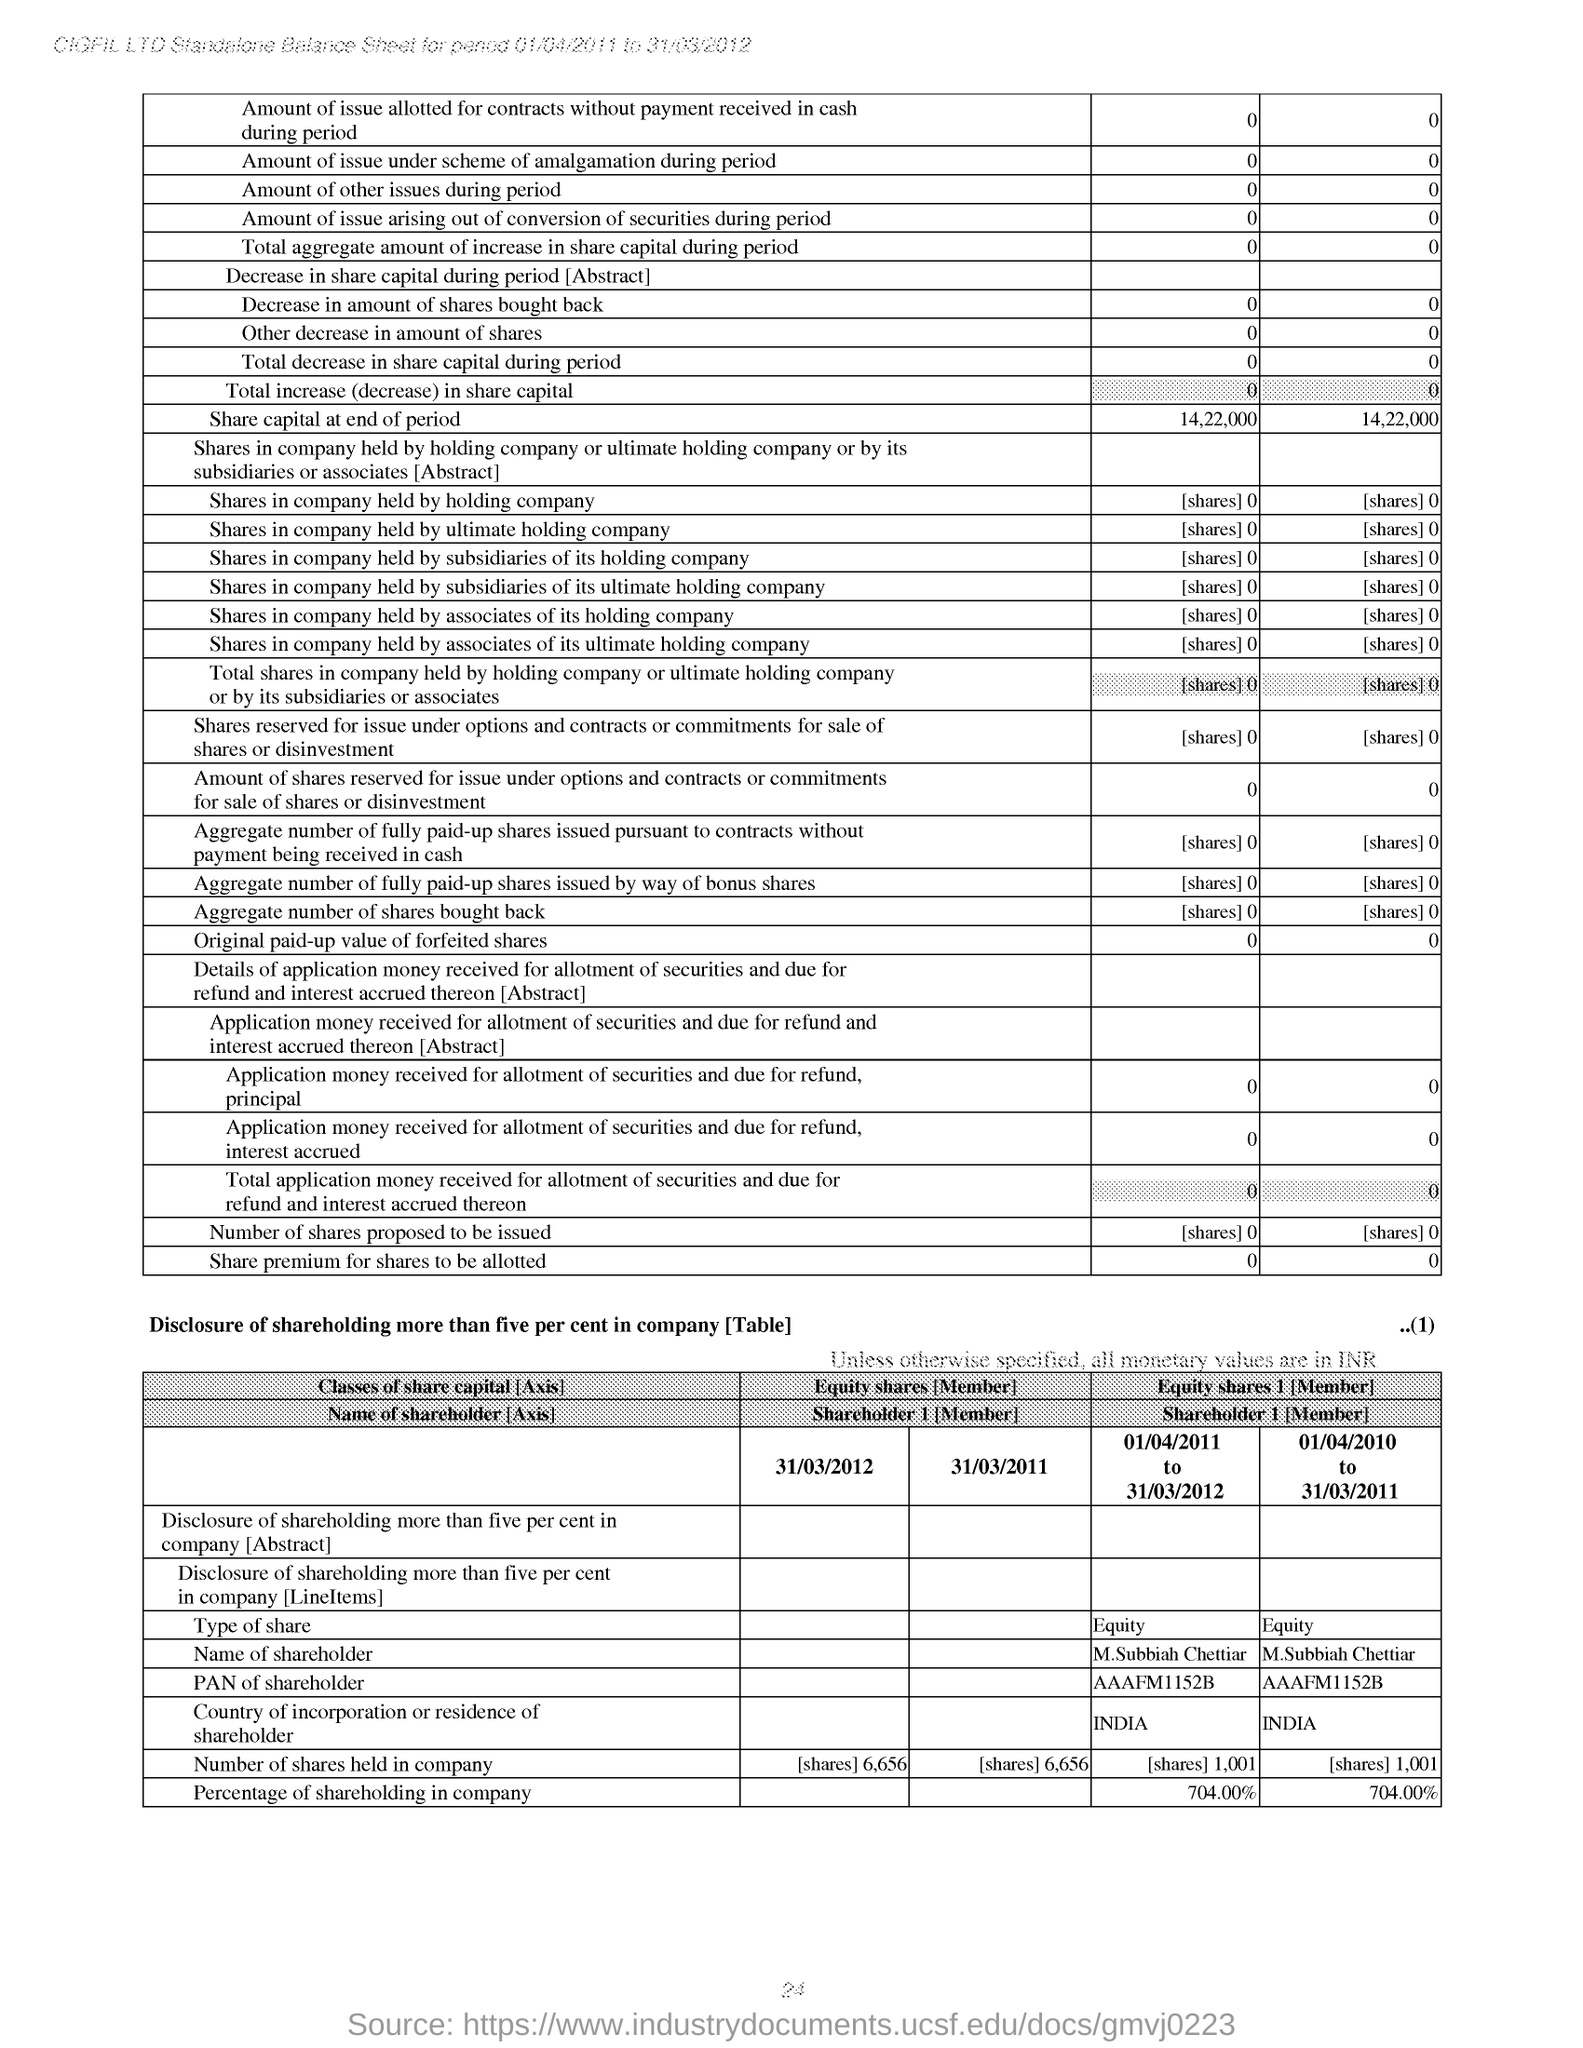What is the value of share capital at the end of period?
Offer a very short reply. 14,22,000. What is the type of share?
Make the answer very short. Equity. 